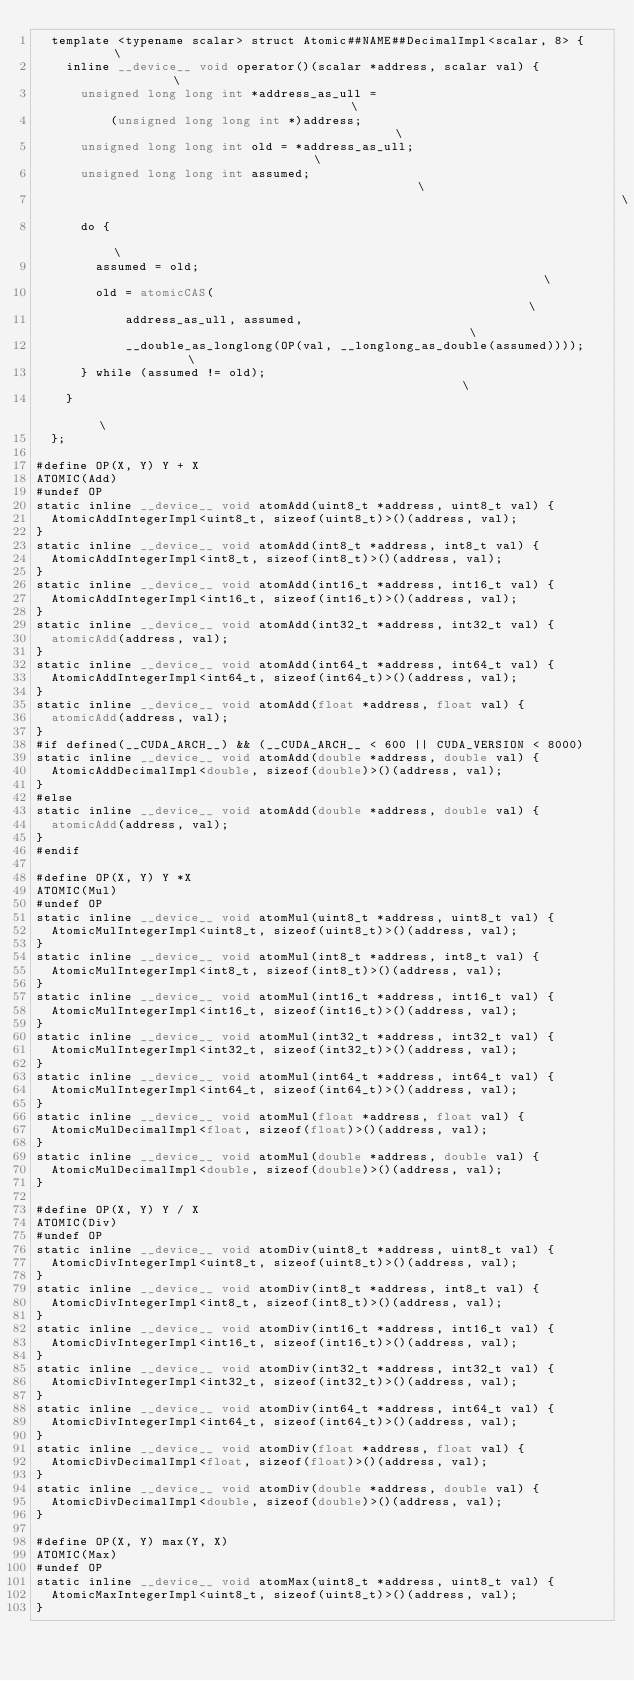Convert code to text. <code><loc_0><loc_0><loc_500><loc_500><_Cuda_>  template <typename scalar> struct Atomic##NAME##DecimalImpl<scalar, 8> {     \
    inline __device__ void operator()(scalar *address, scalar val) {           \
      unsigned long long int *address_as_ull =                                 \
          (unsigned long long int *)address;                                   \
      unsigned long long int old = *address_as_ull;                            \
      unsigned long long int assumed;                                          \
                                                                               \
      do {                                                                     \
        assumed = old;                                                         \
        old = atomicCAS(                                                       \
            address_as_ull, assumed,                                           \
            __double_as_longlong(OP(val, __longlong_as_double(assumed))));     \
      } while (assumed != old);                                                \
    }                                                                          \
  };

#define OP(X, Y) Y + X
ATOMIC(Add)
#undef OP
static inline __device__ void atomAdd(uint8_t *address, uint8_t val) {
  AtomicAddIntegerImpl<uint8_t, sizeof(uint8_t)>()(address, val);
}
static inline __device__ void atomAdd(int8_t *address, int8_t val) {
  AtomicAddIntegerImpl<int8_t, sizeof(int8_t)>()(address, val);
}
static inline __device__ void atomAdd(int16_t *address, int16_t val) {
  AtomicAddIntegerImpl<int16_t, sizeof(int16_t)>()(address, val);
}
static inline __device__ void atomAdd(int32_t *address, int32_t val) {
  atomicAdd(address, val);
}
static inline __device__ void atomAdd(int64_t *address, int64_t val) {
  AtomicAddIntegerImpl<int64_t, sizeof(int64_t)>()(address, val);
}
static inline __device__ void atomAdd(float *address, float val) {
  atomicAdd(address, val);
}
#if defined(__CUDA_ARCH__) && (__CUDA_ARCH__ < 600 || CUDA_VERSION < 8000)
static inline __device__ void atomAdd(double *address, double val) {
  AtomicAddDecimalImpl<double, sizeof(double)>()(address, val);
}
#else
static inline __device__ void atomAdd(double *address, double val) {
  atomicAdd(address, val);
}
#endif

#define OP(X, Y) Y *X
ATOMIC(Mul)
#undef OP
static inline __device__ void atomMul(uint8_t *address, uint8_t val) {
  AtomicMulIntegerImpl<uint8_t, sizeof(uint8_t)>()(address, val);
}
static inline __device__ void atomMul(int8_t *address, int8_t val) {
  AtomicMulIntegerImpl<int8_t, sizeof(int8_t)>()(address, val);
}
static inline __device__ void atomMul(int16_t *address, int16_t val) {
  AtomicMulIntegerImpl<int16_t, sizeof(int16_t)>()(address, val);
}
static inline __device__ void atomMul(int32_t *address, int32_t val) {
  AtomicMulIntegerImpl<int32_t, sizeof(int32_t)>()(address, val);
}
static inline __device__ void atomMul(int64_t *address, int64_t val) {
  AtomicMulIntegerImpl<int64_t, sizeof(int64_t)>()(address, val);
}
static inline __device__ void atomMul(float *address, float val) {
  AtomicMulDecimalImpl<float, sizeof(float)>()(address, val);
}
static inline __device__ void atomMul(double *address, double val) {
  AtomicMulDecimalImpl<double, sizeof(double)>()(address, val);
}

#define OP(X, Y) Y / X
ATOMIC(Div)
#undef OP
static inline __device__ void atomDiv(uint8_t *address, uint8_t val) {
  AtomicDivIntegerImpl<uint8_t, sizeof(uint8_t)>()(address, val);
}
static inline __device__ void atomDiv(int8_t *address, int8_t val) {
  AtomicDivIntegerImpl<int8_t, sizeof(int8_t)>()(address, val);
}
static inline __device__ void atomDiv(int16_t *address, int16_t val) {
  AtomicDivIntegerImpl<int16_t, sizeof(int16_t)>()(address, val);
}
static inline __device__ void atomDiv(int32_t *address, int32_t val) {
  AtomicDivIntegerImpl<int32_t, sizeof(int32_t)>()(address, val);
}
static inline __device__ void atomDiv(int64_t *address, int64_t val) {
  AtomicDivIntegerImpl<int64_t, sizeof(int64_t)>()(address, val);
}
static inline __device__ void atomDiv(float *address, float val) {
  AtomicDivDecimalImpl<float, sizeof(float)>()(address, val);
}
static inline __device__ void atomDiv(double *address, double val) {
  AtomicDivDecimalImpl<double, sizeof(double)>()(address, val);
}

#define OP(X, Y) max(Y, X)
ATOMIC(Max)
#undef OP
static inline __device__ void atomMax(uint8_t *address, uint8_t val) {
  AtomicMaxIntegerImpl<uint8_t, sizeof(uint8_t)>()(address, val);
}</code> 